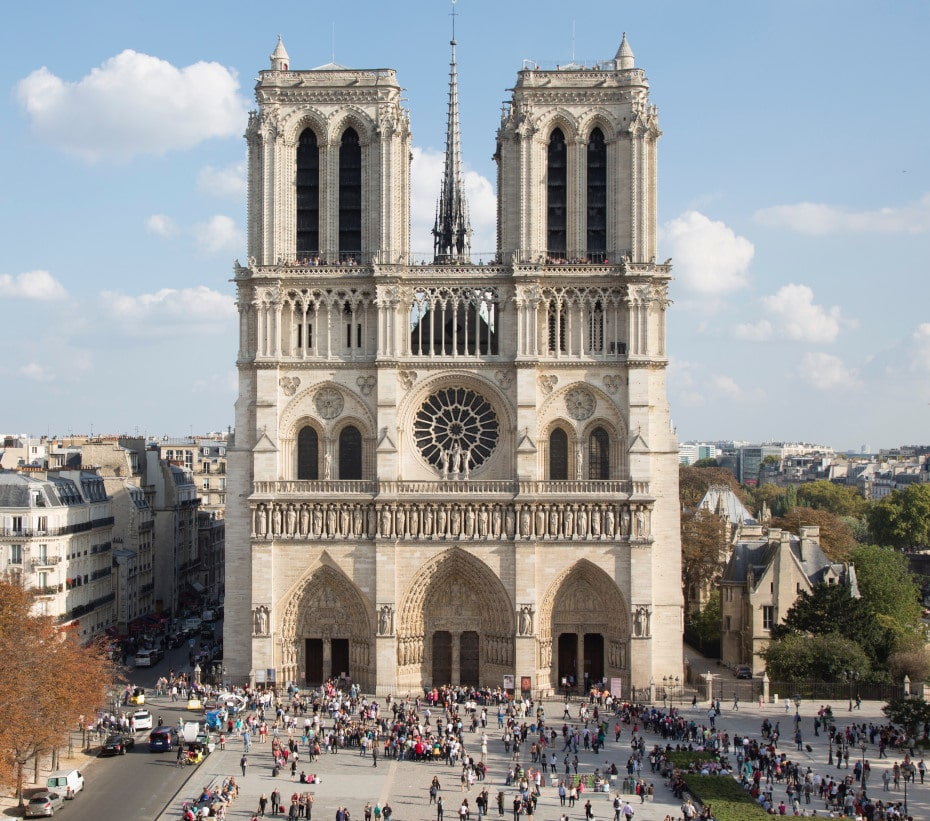What historical events has Notre Dame Cathedral witnessed over the years? Notre Dame Cathedral has been a silent witness to many pivotal moments in history. Since its completion in the 14th century, it has seen numerous historical events, including the coronation of Henry VI of England in 1431, the celebration of the liberation of Paris in 1944, and more recently, the global outpouring of grief and solidarity after the devastating fire in 2019. Each event not only reflects the cathedral's significance in world history but also its role as a beacon of resilience and restoration. 